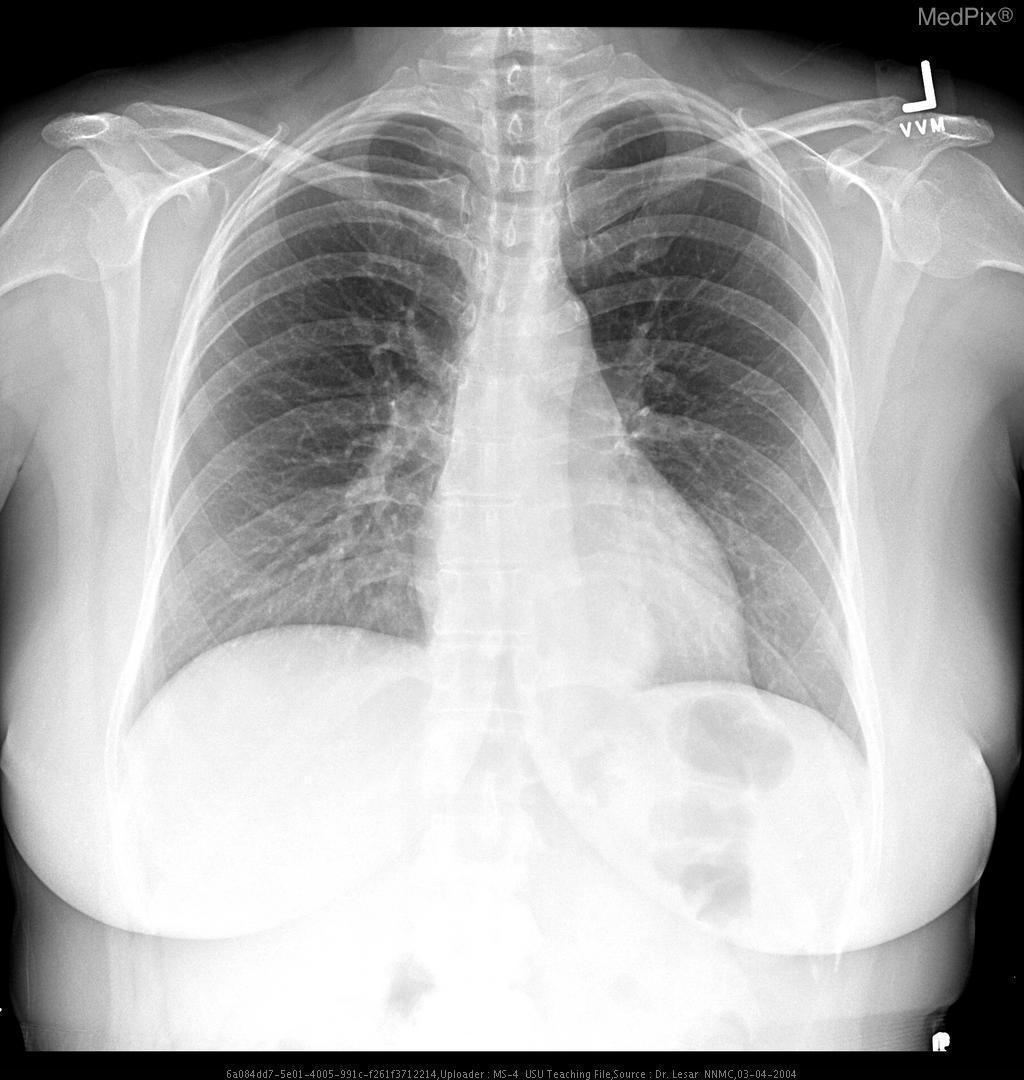Is the heart enlarged?
Concise answer only. Yes. Are the lungs clear?
Give a very brief answer. No. Are there lungs free of consolidation?
Short answer required. Yes. Describe the borders of the lesion.
Write a very short answer. Smooth. How are the borders of the lesion?
Give a very brief answer. Smooth. How would you describe the location of the lesion?
Quick response, please. Retrocardiac. Where is the lesion located?
Write a very short answer. Retrocardiac. 